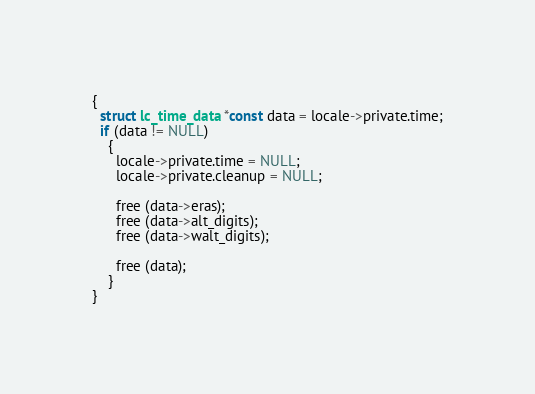Convert code to text. <code><loc_0><loc_0><loc_500><loc_500><_C_>{
  struct lc_time_data *const data = locale->private.time;
  if (data != NULL)
    {
      locale->private.time = NULL;
      locale->private.cleanup = NULL;

      free (data->eras);
      free (data->alt_digits);
      free (data->walt_digits);

      free (data);
    }
}
</code> 